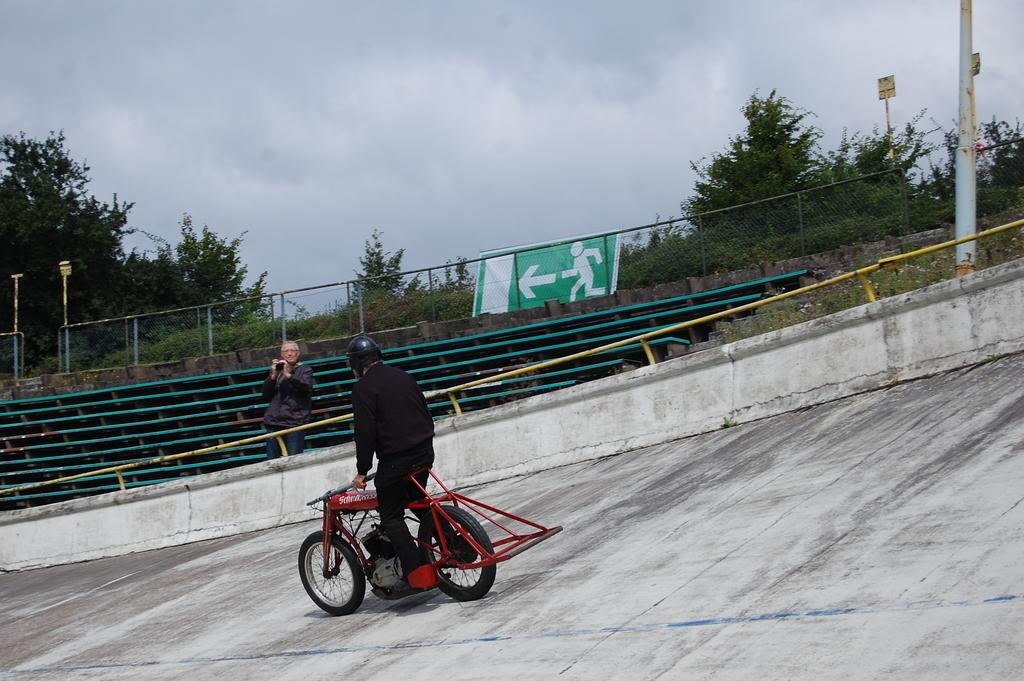What type of natural elements can be seen in the image? There are trees in the image. What man-made structure is present in the image? There is a fence in the image. What additional object can be seen in the image? There is a banner in the image. How many people are in the image? There are two persons in the image. What activity is one of the persons engaged in? One person is riding a bicycle. What type of match is being played in the image? There is no match being played in the image; it features trees, a fence, a banner, and two persons, one of whom is riding a bicycle. What type of harmony is being displayed by the quarter in the image? There is no quarter or harmony present in the image. 